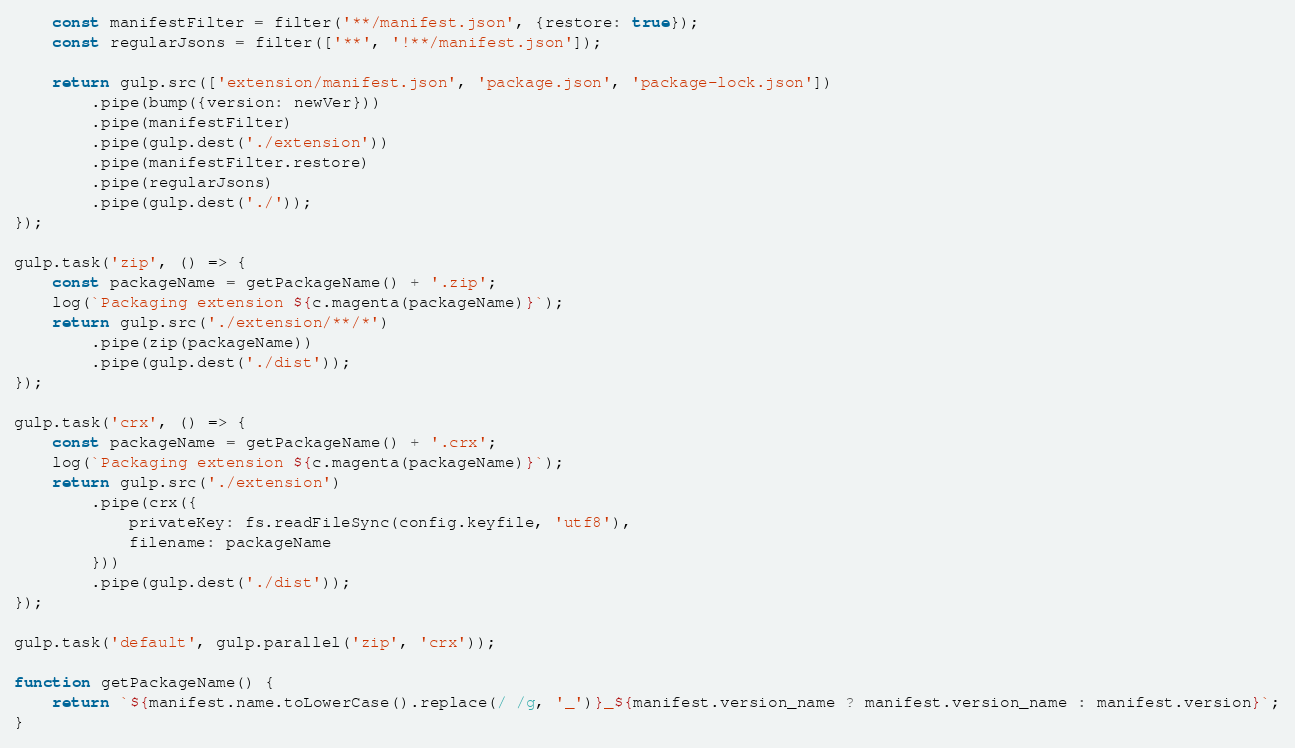Convert code to text. <code><loc_0><loc_0><loc_500><loc_500><_JavaScript_>    const manifestFilter = filter('**/manifest.json', {restore: true});
    const regularJsons = filter(['**', '!**/manifest.json']);

    return gulp.src(['extension/manifest.json', 'package.json', 'package-lock.json'])
        .pipe(bump({version: newVer}))
        .pipe(manifestFilter)
        .pipe(gulp.dest('./extension'))
        .pipe(manifestFilter.restore)
        .pipe(regularJsons)
        .pipe(gulp.dest('./'));
});

gulp.task('zip', () => {
    const packageName = getPackageName() + '.zip';
    log(`Packaging extension ${c.magenta(packageName)}`);
    return gulp.src('./extension/**/*')
        .pipe(zip(packageName))
        .pipe(gulp.dest('./dist'));
});

gulp.task('crx', () => {
    const packageName = getPackageName() + '.crx';
    log(`Packaging extension ${c.magenta(packageName)}`);
    return gulp.src('./extension')
        .pipe(crx({
            privateKey: fs.readFileSync(config.keyfile, 'utf8'),
            filename: packageName
        }))
        .pipe(gulp.dest('./dist'));
});

gulp.task('default', gulp.parallel('zip', 'crx'));

function getPackageName() {
    return `${manifest.name.toLowerCase().replace(/ /g, '_')}_${manifest.version_name ? manifest.version_name : manifest.version}`;
}</code> 